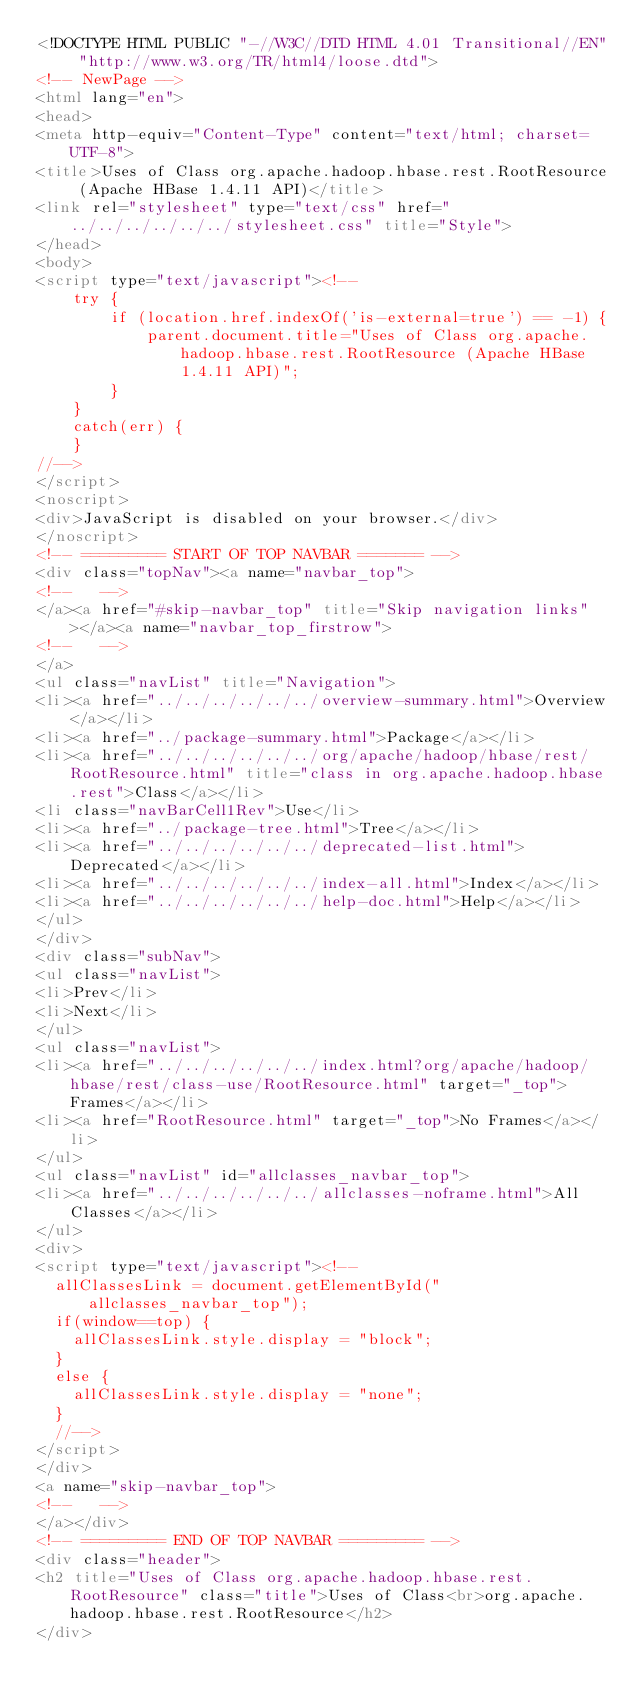Convert code to text. <code><loc_0><loc_0><loc_500><loc_500><_HTML_><!DOCTYPE HTML PUBLIC "-//W3C//DTD HTML 4.01 Transitional//EN" "http://www.w3.org/TR/html4/loose.dtd">
<!-- NewPage -->
<html lang="en">
<head>
<meta http-equiv="Content-Type" content="text/html; charset=UTF-8">
<title>Uses of Class org.apache.hadoop.hbase.rest.RootResource (Apache HBase 1.4.11 API)</title>
<link rel="stylesheet" type="text/css" href="../../../../../../stylesheet.css" title="Style">
</head>
<body>
<script type="text/javascript"><!--
    try {
        if (location.href.indexOf('is-external=true') == -1) {
            parent.document.title="Uses of Class org.apache.hadoop.hbase.rest.RootResource (Apache HBase 1.4.11 API)";
        }
    }
    catch(err) {
    }
//-->
</script>
<noscript>
<div>JavaScript is disabled on your browser.</div>
</noscript>
<!-- ========= START OF TOP NAVBAR ======= -->
<div class="topNav"><a name="navbar_top">
<!--   -->
</a><a href="#skip-navbar_top" title="Skip navigation links"></a><a name="navbar_top_firstrow">
<!--   -->
</a>
<ul class="navList" title="Navigation">
<li><a href="../../../../../../overview-summary.html">Overview</a></li>
<li><a href="../package-summary.html">Package</a></li>
<li><a href="../../../../../../org/apache/hadoop/hbase/rest/RootResource.html" title="class in org.apache.hadoop.hbase.rest">Class</a></li>
<li class="navBarCell1Rev">Use</li>
<li><a href="../package-tree.html">Tree</a></li>
<li><a href="../../../../../../deprecated-list.html">Deprecated</a></li>
<li><a href="../../../../../../index-all.html">Index</a></li>
<li><a href="../../../../../../help-doc.html">Help</a></li>
</ul>
</div>
<div class="subNav">
<ul class="navList">
<li>Prev</li>
<li>Next</li>
</ul>
<ul class="navList">
<li><a href="../../../../../../index.html?org/apache/hadoop/hbase/rest/class-use/RootResource.html" target="_top">Frames</a></li>
<li><a href="RootResource.html" target="_top">No Frames</a></li>
</ul>
<ul class="navList" id="allclasses_navbar_top">
<li><a href="../../../../../../allclasses-noframe.html">All Classes</a></li>
</ul>
<div>
<script type="text/javascript"><!--
  allClassesLink = document.getElementById("allclasses_navbar_top");
  if(window==top) {
    allClassesLink.style.display = "block";
  }
  else {
    allClassesLink.style.display = "none";
  }
  //-->
</script>
</div>
<a name="skip-navbar_top">
<!--   -->
</a></div>
<!-- ========= END OF TOP NAVBAR ========= -->
<div class="header">
<h2 title="Uses of Class org.apache.hadoop.hbase.rest.RootResource" class="title">Uses of Class<br>org.apache.hadoop.hbase.rest.RootResource</h2>
</div></code> 